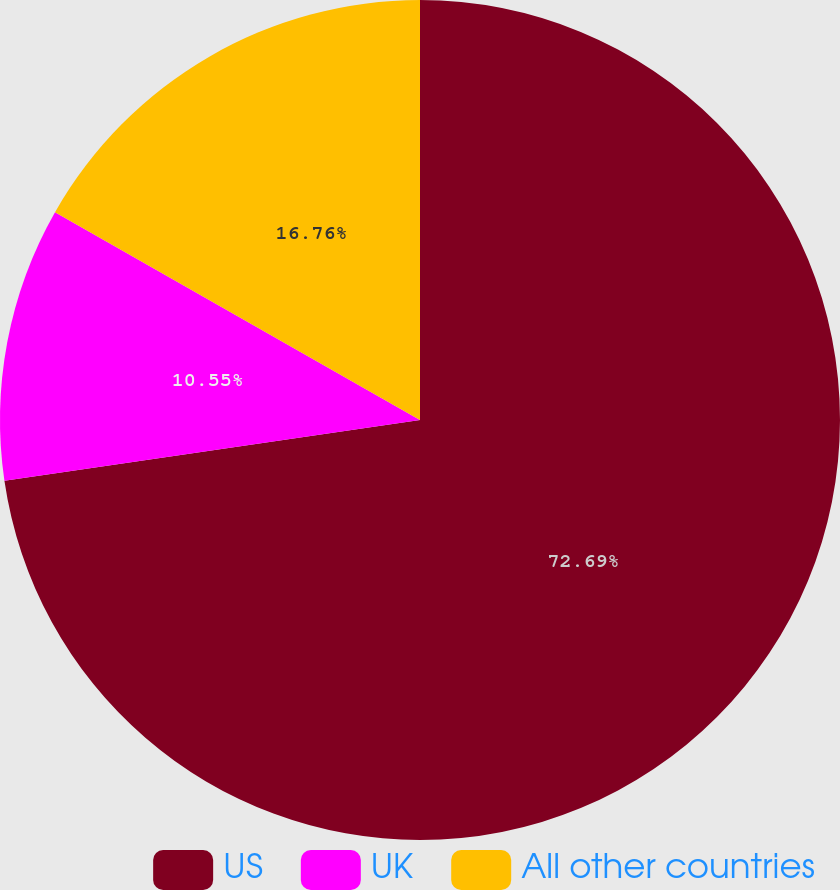Convert chart. <chart><loc_0><loc_0><loc_500><loc_500><pie_chart><fcel>US<fcel>UK<fcel>All other countries<nl><fcel>72.68%<fcel>10.55%<fcel>16.76%<nl></chart> 